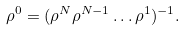<formula> <loc_0><loc_0><loc_500><loc_500>\rho ^ { 0 } = ( \rho ^ { N } \rho ^ { N - 1 } \dots \rho ^ { 1 } ) ^ { - 1 } .</formula> 